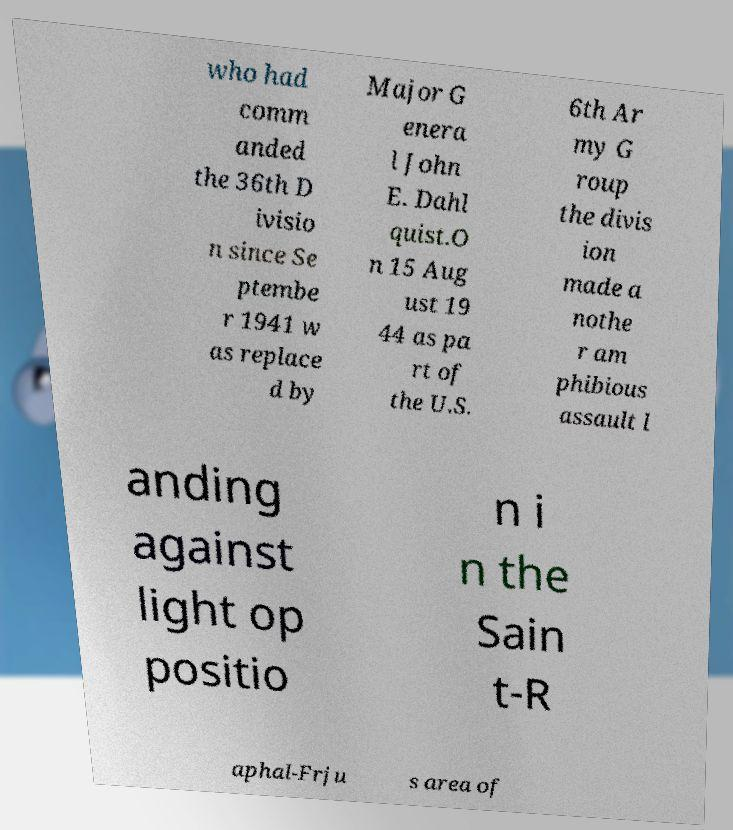Please identify and transcribe the text found in this image. who had comm anded the 36th D ivisio n since Se ptembe r 1941 w as replace d by Major G enera l John E. Dahl quist.O n 15 Aug ust 19 44 as pa rt of the U.S. 6th Ar my G roup the divis ion made a nothe r am phibious assault l anding against light op positio n i n the Sain t-R aphal-Frju s area of 